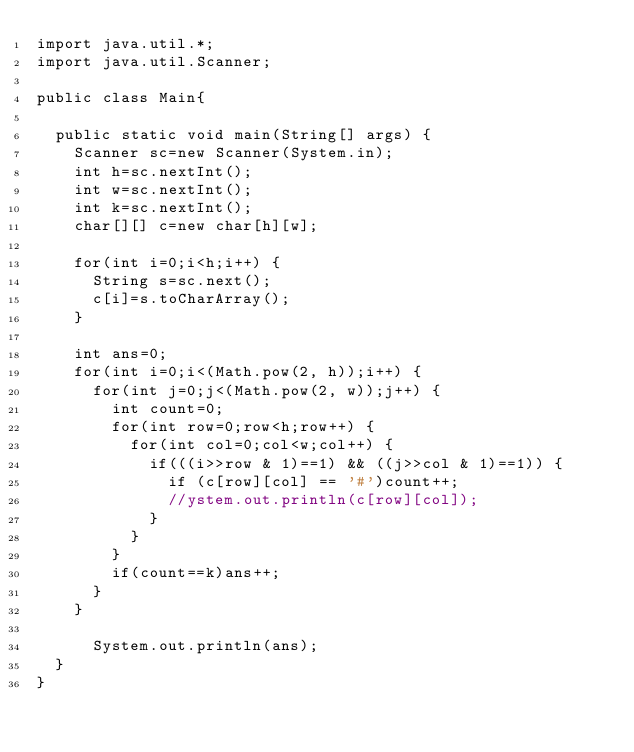<code> <loc_0><loc_0><loc_500><loc_500><_Java_>import java.util.*;
import java.util.Scanner;

public class Main{
	
	public static void main(String[] args) {
		Scanner sc=new Scanner(System.in);
		int h=sc.nextInt();
		int w=sc.nextInt();
		int k=sc.nextInt();
		char[][] c=new char[h][w];
		
		for(int i=0;i<h;i++) {
			String s=sc.next();
			c[i]=s.toCharArray();
		}
		
		int ans=0;
		for(int i=0;i<(Math.pow(2, h));i++) {
			for(int j=0;j<(Math.pow(2, w));j++) {
				int count=0;
				for(int row=0;row<h;row++) {
					for(int col=0;col<w;col++) {
						if(((i>>row & 1)==1) && ((j>>col & 1)==1)) {
							if (c[row][col] == '#')count++;
							//ystem.out.println(c[row][col]);
						}
					}
				}	
				if(count==k)ans++;
			}
		}
		
	    System.out.println(ans);
	}
}
</code> 